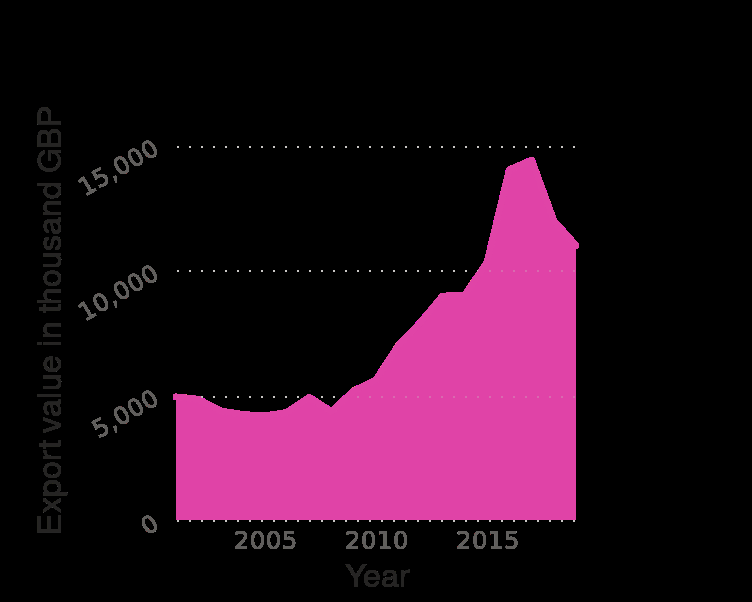<image>
What is the range of years for which the data is plotted?  The data is plotted for the years from 2001 to 2019. Describe the following image in detail Here a is a area plot named Value of pepper , peppers and capsicum exported from the United Kingdom (UK) from 2001 to 2019 (in 1,000 GBP). There is a linear scale with a minimum of 2005 and a maximum of 2015 along the x-axis, marked Year. Export value in thousand GBP is drawn with a linear scale with a minimum of 0 and a maximum of 15,000 on the y-axis. 